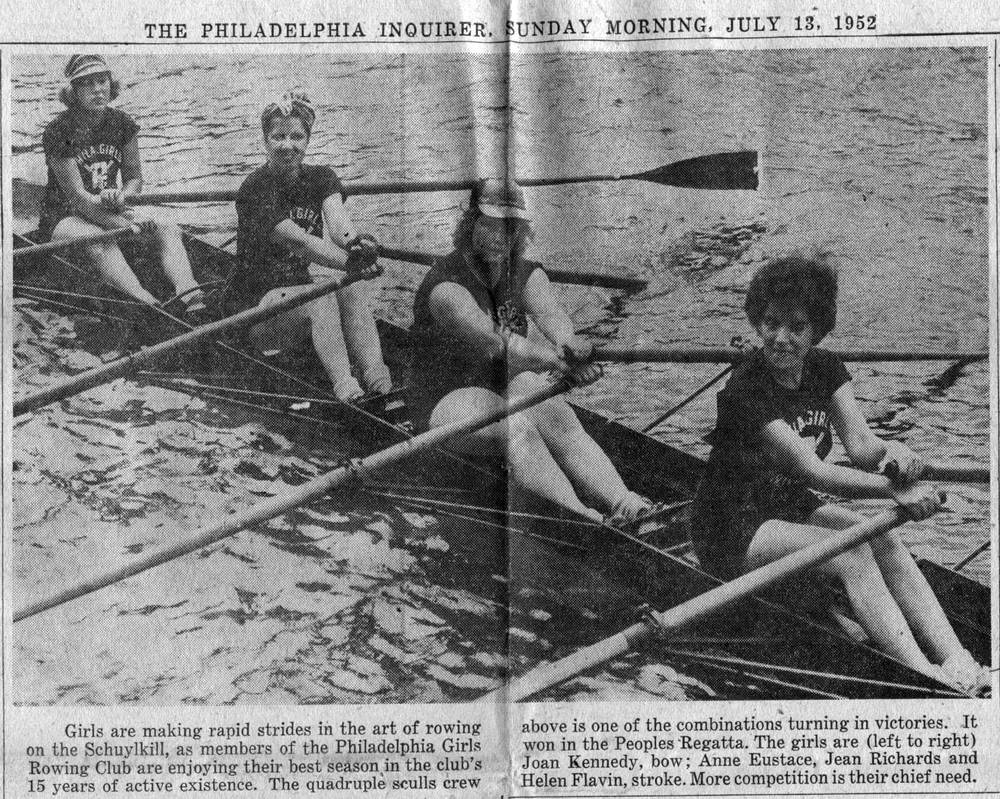Considering the water conditions and the position of the oars, what can be inferred about the speed and stability of the boat? The brisk ripple patterns on the water's surface around the boat suggest that it's moving swiftly, a testament to the rowers' athleticism and the synchronization of their strokes. The oars shown at different positions indicate a moment within a coordinated rowing cycle, capturing the dynamic rhythm of the sport. Despite these varying oar positions, the lack of any discernible tilt signifies a well-balanced vessel, pointing to the rowers’ adept management of stability. Additionally, the minimal wake trailing the scull implies a smooth, efficient traverse, hinting at a competitive pace likely honed through diligent practice. 